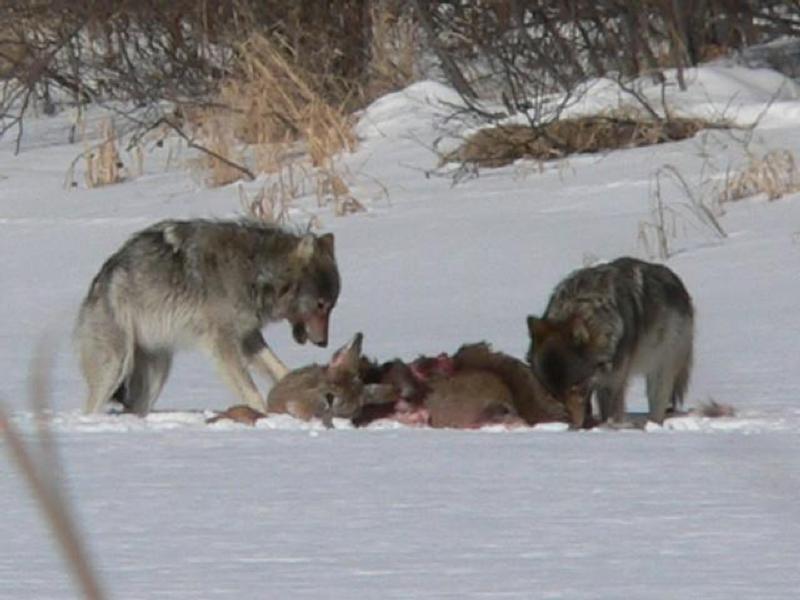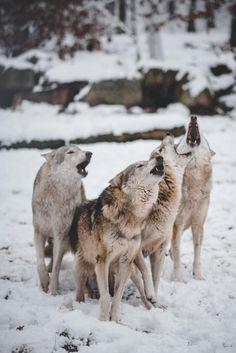The first image is the image on the left, the second image is the image on the right. Analyze the images presented: Is the assertion "Some of the dogs are howling with their heads pointed up." valid? Answer yes or no. Yes. The first image is the image on the left, the second image is the image on the right. Analyze the images presented: Is the assertion "An image shows at least four wolves posed right by a large upright tree trunk." valid? Answer yes or no. No. 